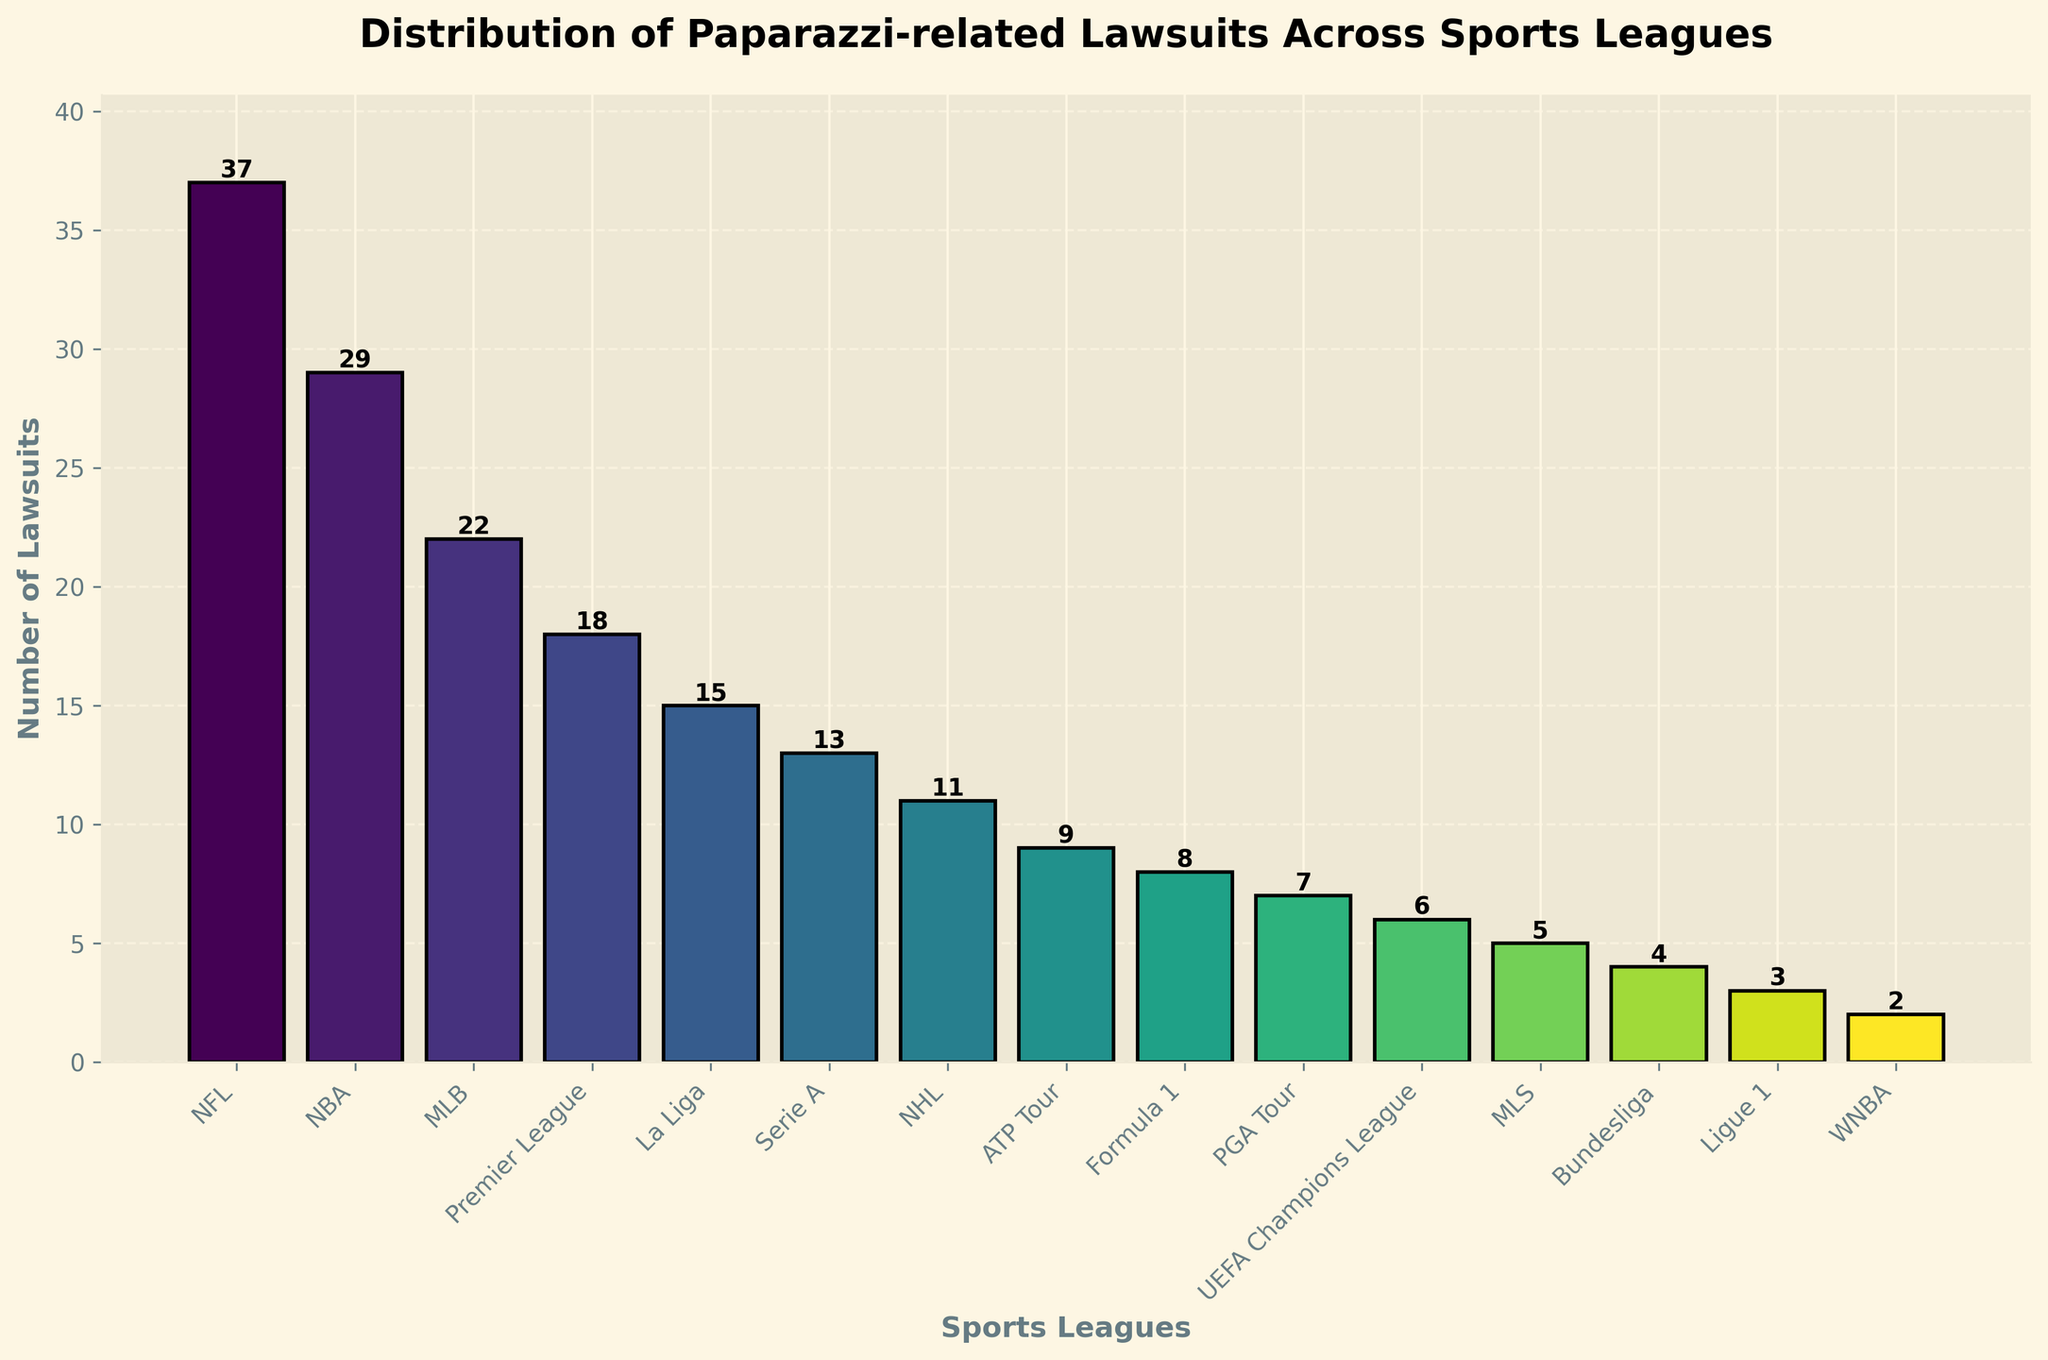Which league has the highest number of paparazzi-related lawsuits? The tallest bar in the chart represents the league with the highest number of lawsuits. This bar, which is associated with the NFL, has a height corresponding to 37 lawsuits.
Answer: NFL Which league has fewer lawsuits, the Premier League or La Liga? To find this, compare the heights of the bars for the Premier League and La Liga. The Premier League bar is taller at 18 lawsuits compared to La Liga's bar at 15 lawsuits.
Answer: La Liga What is the total number of lawsuits across the top three leagues? Sum the number of lawsuits for the NFL (37), NBA (29), and MLB (22). Adding these numbers: 37 + 29 + 22 = 88 lawsuits.
Answer: 88 lawsuits How many leagues have fewer than 10 lawsuits? Count the number of bars with heights less than 10. This includes the ATP Tour (9), Formula 1 (8), PGA Tour (7), UEFA Champions League (6), MLS (5), Bundesliga (4), Ligue 1 (3), and WNBA (2). There are 8 such leagues.
Answer: 8 leagues Which league is ranked third in the number of lawsuits? Arrange the leagues by the heights of their bars in descending order. The NFL is first, NBA second, and MLB third with 22 lawsuits.
Answer: MLB What is the average number of lawsuits for all leagues? Sum the number of lawsuits across all leagues and then divide by the number of leagues. The sum is 37 + 29 + 22 + 18 + 15 + 13 + 11 + 9 + 8 + 7 + 6 + 5 + 4 + 3 + 2 = 189. There are 15 leagues. So, the average is 189 / 15 = 12.6 lawsuits.
Answer: 12.6 lawsuits How many more lawsuits does the NFL have compared to the WNBA? Subtract the number of lawsuits of the WNBA (2) from the number of NFL lawsuits (37). 37 - 2 = 35 lawsuits.
Answer: 35 lawsuits Which league has more lawsuits, Serie A or NHL, and by how many? Compare the heights of their bars. Serie A has 13 lawsuits, and NHL has 11 lawsuits. 13 - 11 = 2 more lawsuits for Serie A.
Answer: Serie A, 2 lawsuits What is the combined number of lawsuits for the UEFA Champions League, MLS, and Bundesliga? Sum the number of lawsuits for these leagues: 6 (UEFA Champions League) + 5 (MLS) + 4 (Bundesliga). 6 + 5 + 4 = 15 lawsuits.
Answer: 15 lawsuits What is the median number of lawsuits among all leagues? Arrange the lawsuit numbers in ascending order (2, 3, 4, 5, 6, 7, 8, 9, 11, 13, 15, 18, 22, 29, 37) and find the middle value. The 8th value in this 15-number sequence is the median.
Answer: 11 lawsuits 